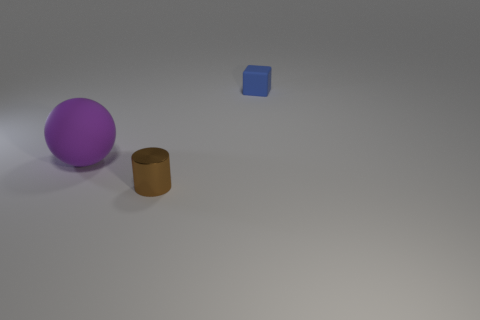Add 2 large blue metallic blocks. How many objects exist? 5 Subtract all spheres. How many objects are left? 2 Add 3 balls. How many balls are left? 4 Add 3 red rubber spheres. How many red rubber spheres exist? 3 Subtract 0 red blocks. How many objects are left? 3 Subtract all small metallic things. Subtract all tiny spheres. How many objects are left? 2 